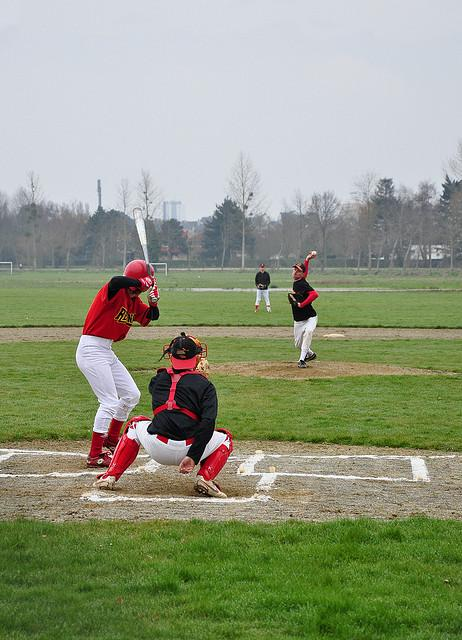What is the opposite form of this pitch? Please explain your reasoning. underhand. Most all pitchers in baseball throw overhand, so the opposite is under. 